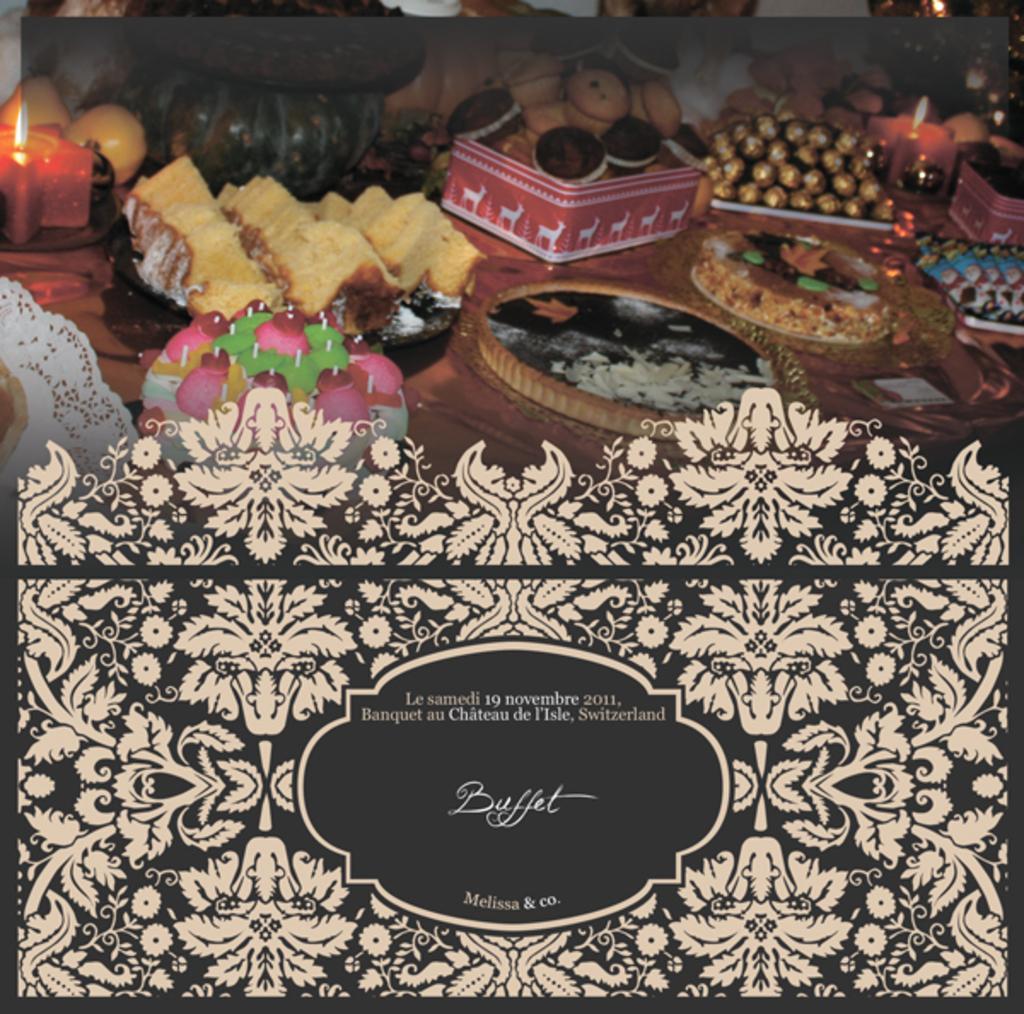Please provide a concise description of this image. In this picture we can see table. On the table we can see box, cakes, bread, chocolates, covers, candles and other objects. On the top we can see couch. On the bottom we can see painting on the glass. 